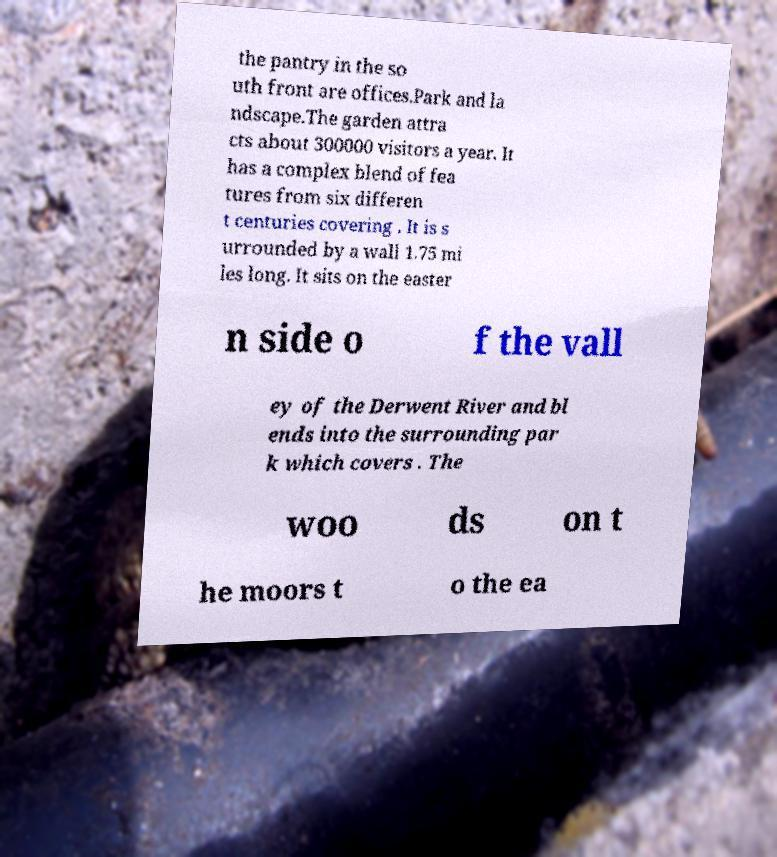For documentation purposes, I need the text within this image transcribed. Could you provide that? the pantry in the so uth front are offices.Park and la ndscape.The garden attra cts about 300000 visitors a year. It has a complex blend of fea tures from six differen t centuries covering . It is s urrounded by a wall 1.75 mi les long. It sits on the easter n side o f the vall ey of the Derwent River and bl ends into the surrounding par k which covers . The woo ds on t he moors t o the ea 